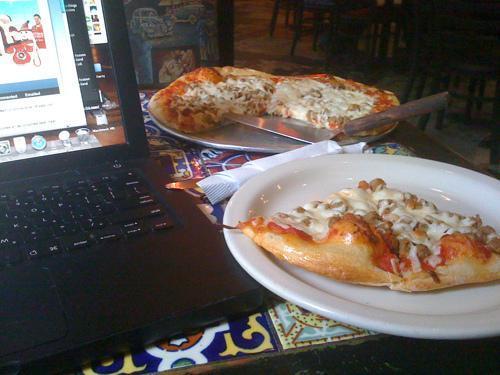How many pizza are in the plates?
Give a very brief answer. 2. How many plates are there?
Give a very brief answer. 2. How many slices of pizza on the white plate?
Give a very brief answer. 2. How many chairs are in the picture?
Give a very brief answer. 2. How many pizzas are there?
Give a very brief answer. 3. How many people are there?
Give a very brief answer. 0. 